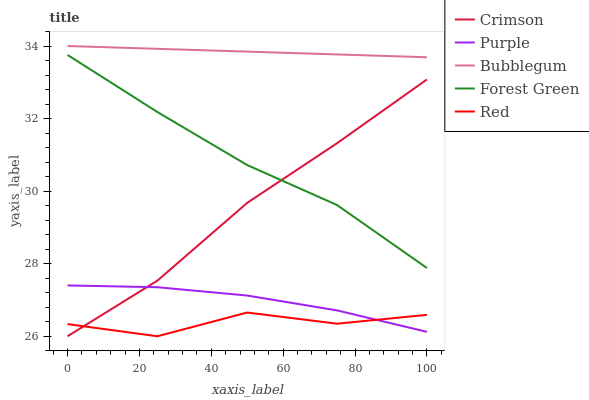Does Purple have the minimum area under the curve?
Answer yes or no. No. Does Purple have the maximum area under the curve?
Answer yes or no. No. Is Purple the smoothest?
Answer yes or no. No. Is Purple the roughest?
Answer yes or no. No. Does Purple have the lowest value?
Answer yes or no. No. Does Purple have the highest value?
Answer yes or no. No. Is Forest Green less than Bubblegum?
Answer yes or no. Yes. Is Bubblegum greater than Forest Green?
Answer yes or no. Yes. Does Forest Green intersect Bubblegum?
Answer yes or no. No. 